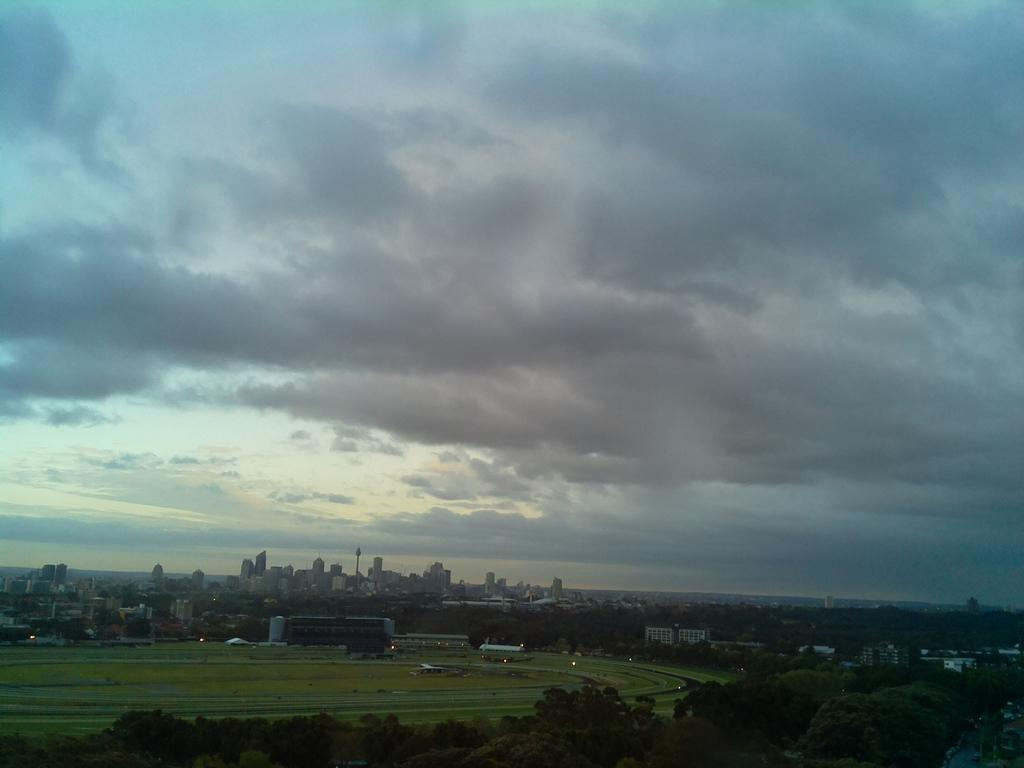What type of natural elements can be seen in the image? There are many trees in the image. What type of man-made structures are visible in the background? There are buildings in the background of the image. What part of the natural environment is visible in the image? The sky is visible in the image. What is the condition of the sky in the image? Clouds are present in the sky. Can you see any ghosts interacting with the trees in the image? There are no ghosts present in the image; it only features trees, buildings, and the sky. What type of authority figure can be seen in the image? There is no authority figure present in the image. 